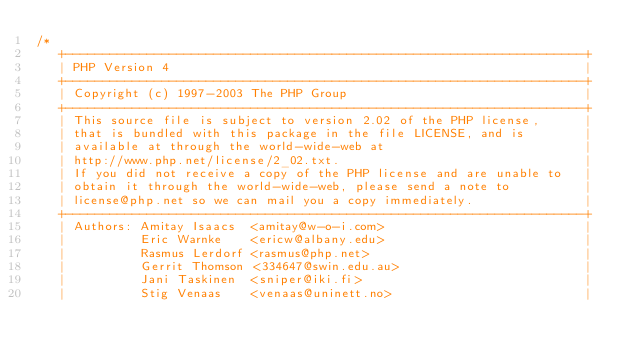<code> <loc_0><loc_0><loc_500><loc_500><_C_>/*
   +----------------------------------------------------------------------+
   | PHP Version 4                                                        |
   +----------------------------------------------------------------------+
   | Copyright (c) 1997-2003 The PHP Group                                |
   +----------------------------------------------------------------------+
   | This source file is subject to version 2.02 of the PHP license,      |
   | that is bundled with this package in the file LICENSE, and is        |
   | available at through the world-wide-web at                           |
   | http://www.php.net/license/2_02.txt.                                 |
   | If you did not receive a copy of the PHP license and are unable to   |
   | obtain it through the world-wide-web, please send a note to          |
   | license@php.net so we can mail you a copy immediately.               |
   +----------------------------------------------------------------------+
   | Authors: Amitay Isaacs  <amitay@w-o-i.com>                           |
   |          Eric Warnke    <ericw@albany.edu>                           |
   |          Rasmus Lerdorf <rasmus@php.net>                             |
   |          Gerrit Thomson <334647@swin.edu.au>                         |
   |          Jani Taskinen  <sniper@iki.fi>                              |
   |          Stig Venaas    <venaas@uninett.no>                          |</code> 